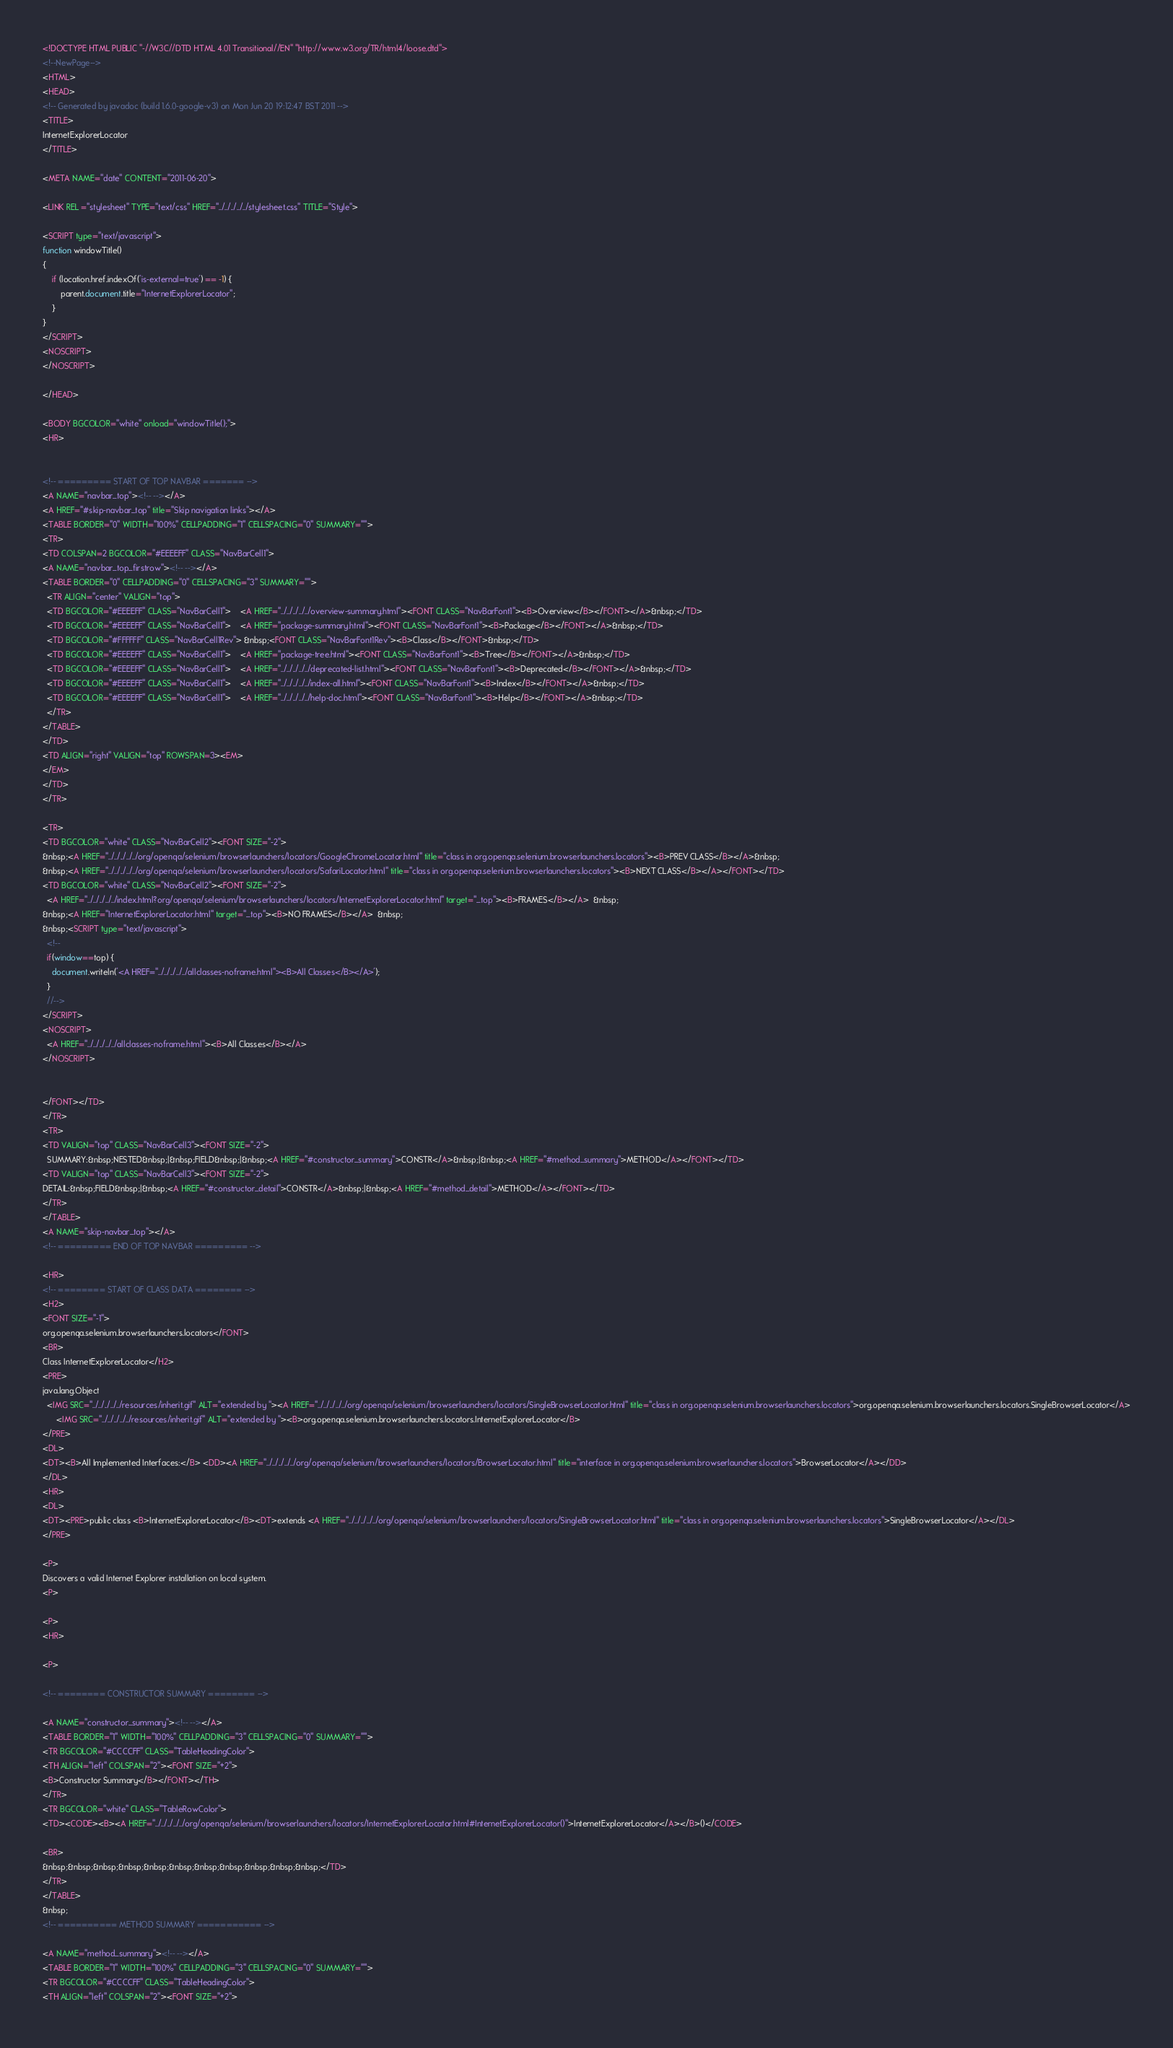Convert code to text. <code><loc_0><loc_0><loc_500><loc_500><_HTML_><!DOCTYPE HTML PUBLIC "-//W3C//DTD HTML 4.01 Transitional//EN" "http://www.w3.org/TR/html4/loose.dtd">
<!--NewPage-->
<HTML>
<HEAD>
<!-- Generated by javadoc (build 1.6.0-google-v3) on Mon Jun 20 19:12:47 BST 2011 -->
<TITLE>
InternetExplorerLocator
</TITLE>

<META NAME="date" CONTENT="2011-06-20">

<LINK REL ="stylesheet" TYPE="text/css" HREF="../../../../../stylesheet.css" TITLE="Style">

<SCRIPT type="text/javascript">
function windowTitle()
{
    if (location.href.indexOf('is-external=true') == -1) {
        parent.document.title="InternetExplorerLocator";
    }
}
</SCRIPT>
<NOSCRIPT>
</NOSCRIPT>

</HEAD>

<BODY BGCOLOR="white" onload="windowTitle();">
<HR>


<!-- ========= START OF TOP NAVBAR ======= -->
<A NAME="navbar_top"><!-- --></A>
<A HREF="#skip-navbar_top" title="Skip navigation links"></A>
<TABLE BORDER="0" WIDTH="100%" CELLPADDING="1" CELLSPACING="0" SUMMARY="">
<TR>
<TD COLSPAN=2 BGCOLOR="#EEEEFF" CLASS="NavBarCell1">
<A NAME="navbar_top_firstrow"><!-- --></A>
<TABLE BORDER="0" CELLPADDING="0" CELLSPACING="3" SUMMARY="">
  <TR ALIGN="center" VALIGN="top">
  <TD BGCOLOR="#EEEEFF" CLASS="NavBarCell1">    <A HREF="../../../../../overview-summary.html"><FONT CLASS="NavBarFont1"><B>Overview</B></FONT></A>&nbsp;</TD>
  <TD BGCOLOR="#EEEEFF" CLASS="NavBarCell1">    <A HREF="package-summary.html"><FONT CLASS="NavBarFont1"><B>Package</B></FONT></A>&nbsp;</TD>
  <TD BGCOLOR="#FFFFFF" CLASS="NavBarCell1Rev"> &nbsp;<FONT CLASS="NavBarFont1Rev"><B>Class</B></FONT>&nbsp;</TD>
  <TD BGCOLOR="#EEEEFF" CLASS="NavBarCell1">    <A HREF="package-tree.html"><FONT CLASS="NavBarFont1"><B>Tree</B></FONT></A>&nbsp;</TD>
  <TD BGCOLOR="#EEEEFF" CLASS="NavBarCell1">    <A HREF="../../../../../deprecated-list.html"><FONT CLASS="NavBarFont1"><B>Deprecated</B></FONT></A>&nbsp;</TD>
  <TD BGCOLOR="#EEEEFF" CLASS="NavBarCell1">    <A HREF="../../../../../index-all.html"><FONT CLASS="NavBarFont1"><B>Index</B></FONT></A>&nbsp;</TD>
  <TD BGCOLOR="#EEEEFF" CLASS="NavBarCell1">    <A HREF="../../../../../help-doc.html"><FONT CLASS="NavBarFont1"><B>Help</B></FONT></A>&nbsp;</TD>
  </TR>
</TABLE>
</TD>
<TD ALIGN="right" VALIGN="top" ROWSPAN=3><EM>
</EM>
</TD>
</TR>

<TR>
<TD BGCOLOR="white" CLASS="NavBarCell2"><FONT SIZE="-2">
&nbsp;<A HREF="../../../../../org/openqa/selenium/browserlaunchers/locators/GoogleChromeLocator.html" title="class in org.openqa.selenium.browserlaunchers.locators"><B>PREV CLASS</B></A>&nbsp;
&nbsp;<A HREF="../../../../../org/openqa/selenium/browserlaunchers/locators/SafariLocator.html" title="class in org.openqa.selenium.browserlaunchers.locators"><B>NEXT CLASS</B></A></FONT></TD>
<TD BGCOLOR="white" CLASS="NavBarCell2"><FONT SIZE="-2">
  <A HREF="../../../../../index.html?org/openqa/selenium/browserlaunchers/locators/InternetExplorerLocator.html" target="_top"><B>FRAMES</B></A>  &nbsp;
&nbsp;<A HREF="InternetExplorerLocator.html" target="_top"><B>NO FRAMES</B></A>  &nbsp;
&nbsp;<SCRIPT type="text/javascript">
  <!--
  if(window==top) {
    document.writeln('<A HREF="../../../../../allclasses-noframe.html"><B>All Classes</B></A>');
  }
  //-->
</SCRIPT>
<NOSCRIPT>
  <A HREF="../../../../../allclasses-noframe.html"><B>All Classes</B></A>
</NOSCRIPT>


</FONT></TD>
</TR>
<TR>
<TD VALIGN="top" CLASS="NavBarCell3"><FONT SIZE="-2">
  SUMMARY:&nbsp;NESTED&nbsp;|&nbsp;FIELD&nbsp;|&nbsp;<A HREF="#constructor_summary">CONSTR</A>&nbsp;|&nbsp;<A HREF="#method_summary">METHOD</A></FONT></TD>
<TD VALIGN="top" CLASS="NavBarCell3"><FONT SIZE="-2">
DETAIL:&nbsp;FIELD&nbsp;|&nbsp;<A HREF="#constructor_detail">CONSTR</A>&nbsp;|&nbsp;<A HREF="#method_detail">METHOD</A></FONT></TD>
</TR>
</TABLE>
<A NAME="skip-navbar_top"></A>
<!-- ========= END OF TOP NAVBAR ========= -->

<HR>
<!-- ======== START OF CLASS DATA ======== -->
<H2>
<FONT SIZE="-1">
org.openqa.selenium.browserlaunchers.locators</FONT>
<BR>
Class InternetExplorerLocator</H2>
<PRE>
java.lang.Object
  <IMG SRC="../../../../../resources/inherit.gif" ALT="extended by "><A HREF="../../../../../org/openqa/selenium/browserlaunchers/locators/SingleBrowserLocator.html" title="class in org.openqa.selenium.browserlaunchers.locators">org.openqa.selenium.browserlaunchers.locators.SingleBrowserLocator</A>
      <IMG SRC="../../../../../resources/inherit.gif" ALT="extended by "><B>org.openqa.selenium.browserlaunchers.locators.InternetExplorerLocator</B>
</PRE>
<DL>
<DT><B>All Implemented Interfaces:</B> <DD><A HREF="../../../../../org/openqa/selenium/browserlaunchers/locators/BrowserLocator.html" title="interface in org.openqa.selenium.browserlaunchers.locators">BrowserLocator</A></DD>
</DL>
<HR>
<DL>
<DT><PRE>public class <B>InternetExplorerLocator</B><DT>extends <A HREF="../../../../../org/openqa/selenium/browserlaunchers/locators/SingleBrowserLocator.html" title="class in org.openqa.selenium.browserlaunchers.locators">SingleBrowserLocator</A></DL>
</PRE>

<P>
Discovers a valid Internet Explorer installation on local system.
<P>

<P>
<HR>

<P>

<!-- ======== CONSTRUCTOR SUMMARY ======== -->

<A NAME="constructor_summary"><!-- --></A>
<TABLE BORDER="1" WIDTH="100%" CELLPADDING="3" CELLSPACING="0" SUMMARY="">
<TR BGCOLOR="#CCCCFF" CLASS="TableHeadingColor">
<TH ALIGN="left" COLSPAN="2"><FONT SIZE="+2">
<B>Constructor Summary</B></FONT></TH>
</TR>
<TR BGCOLOR="white" CLASS="TableRowColor">
<TD><CODE><B><A HREF="../../../../../org/openqa/selenium/browserlaunchers/locators/InternetExplorerLocator.html#InternetExplorerLocator()">InternetExplorerLocator</A></B>()</CODE>

<BR>
&nbsp;&nbsp;&nbsp;&nbsp;&nbsp;&nbsp;&nbsp;&nbsp;&nbsp;&nbsp;&nbsp;</TD>
</TR>
</TABLE>
&nbsp;
<!-- ========== METHOD SUMMARY =========== -->

<A NAME="method_summary"><!-- --></A>
<TABLE BORDER="1" WIDTH="100%" CELLPADDING="3" CELLSPACING="0" SUMMARY="">
<TR BGCOLOR="#CCCCFF" CLASS="TableHeadingColor">
<TH ALIGN="left" COLSPAN="2"><FONT SIZE="+2"></code> 